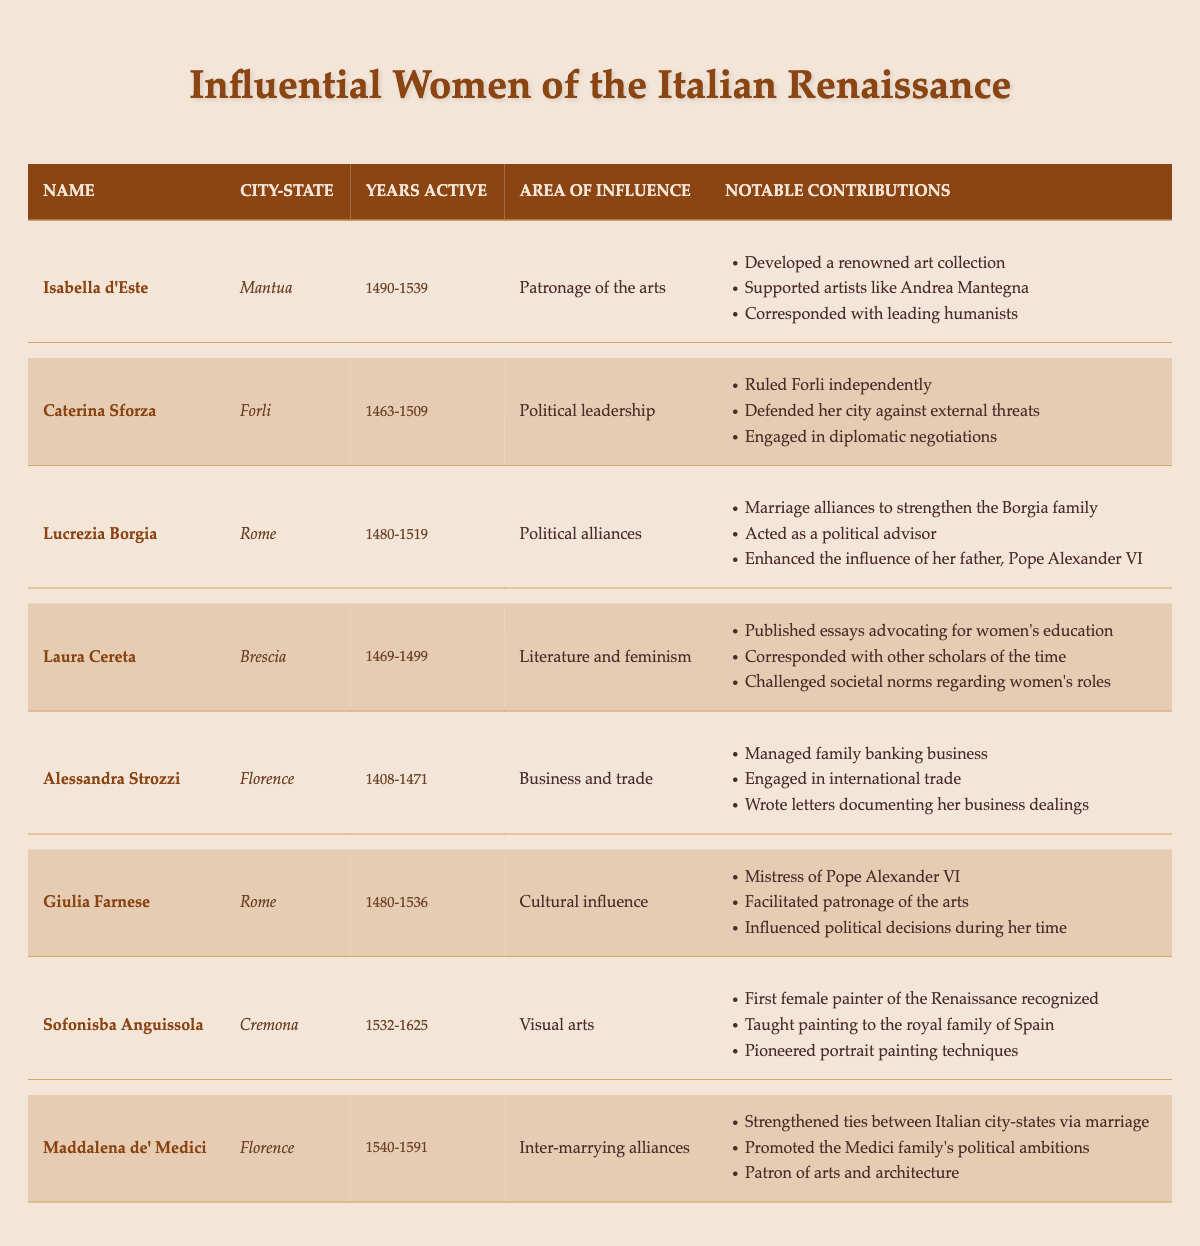What city-state was Isabella d'Este associated with? Isabella d'Este is listed under the city-state Mantua in the table.
Answer: Mantua How many years was Caterina Sforza active? Caterina Sforza was active from 1463 to 1509. To find the total years active, subtract 1463 from 1509, which equals 46 years.
Answer: 46 years Did Lucrezia Borgia contribute to political alliances? The table indicates that Lucrezia Borgia's area of influence was political alliances, confirming she did contribute in this area.
Answer: Yes Which woman is known for her work in visual arts? The table lists Sofonisba Anguissola under the area of influence as visual arts, making her the woman known for this.
Answer: Sofonisba Anguissola What notable contribution did Laura Cereta make regarding women's education? Laura Cereta published essays advocating for women's education, which is stated in her notable contributions section.
Answer: Advocated for women's education Which two figures were active in Florence and what were their areas of influence? The table shows Alessandra Strozzi and Maddalena de' Medici were both active in Florence. Strozzi influenced business and trade, while de' Medici influenced inter-marrying alliances.
Answer: Alessandra Strozzi: Business and Trade; Maddalena de' Medici: Inter-marrying Alliances How many women listed were active in the 1500s? From the table, Isabella d'Este (1490-1539), Lucrezia Borgia (1480-1519), Giulia Farnese (1480-1536), Sofonisba Anguissola (1532-1625), and Maddalena de' Medici (1540-1591) were all active in the 1500s, totaling to 5 women.
Answer: 5 women Which woman's influence was primarily in literature and feminism? The table states that Laura Cereta focused on literature and feminism, making her the relevant figure for this area.
Answer: Laura Cereta What were the notable contributions of Giulia Farnese? Giulia Farnese's notable contributions include being the mistress of Pope Alexander VI, facilitating patronage of the arts, and influencing political decisions.
Answer: Mistress of Pope Alexander VI, facilitated patronage of the arts, influenced political decisions Identify the areas of influence for the women from Rome listed in the table. The table shows that Lucrezia Borgia influenced political alliances, and Giulia Farnese influenced cultural aspects. Thus, the areas are political alliances and cultural influence.
Answer: Political alliances; Cultural influence 